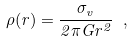Convert formula to latex. <formula><loc_0><loc_0><loc_500><loc_500>\rho ( r ) = \frac { \sigma _ { v } } { 2 \pi G r ^ { 2 } } \ ,</formula> 